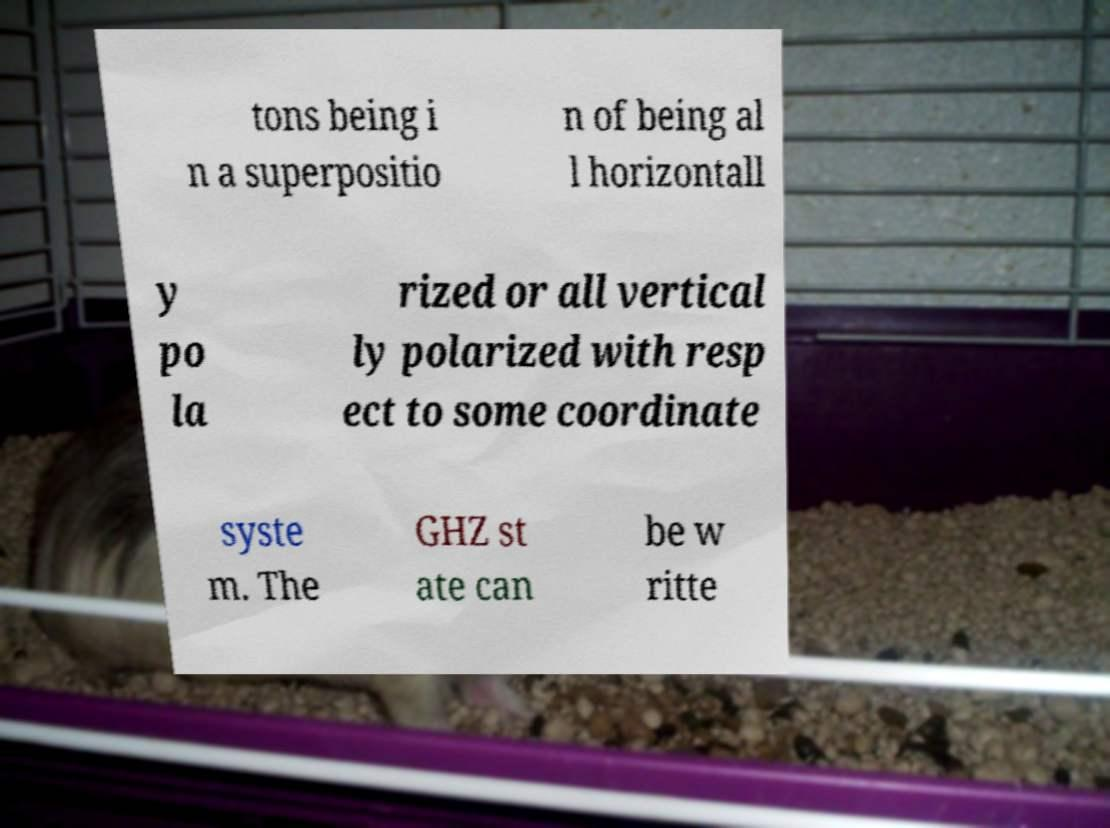Can you read and provide the text displayed in the image?This photo seems to have some interesting text. Can you extract and type it out for me? tons being i n a superpositio n of being al l horizontall y po la rized or all vertical ly polarized with resp ect to some coordinate syste m. The GHZ st ate can be w ritte 